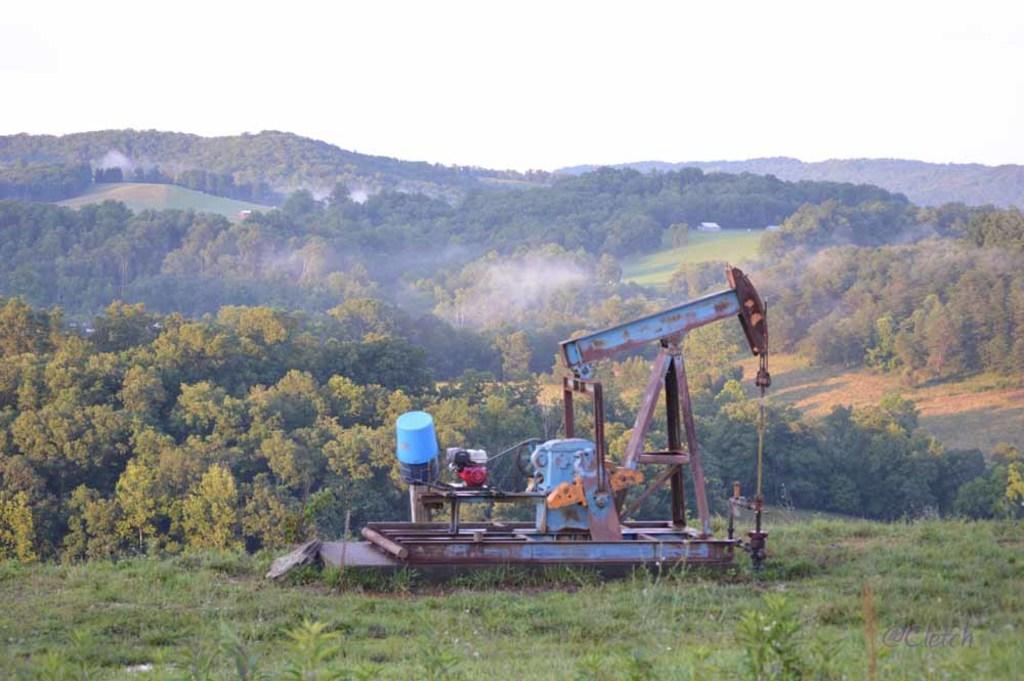What is the main object in the image? There is a machine with iron rods in the image. What can be seen on the ground in the image? There are plants on the ground in the image. What is visible in the background of the image? There are trees and the sky visible in the background of the image. Can you describe any additional features of the image? There is a watermark in the right bottom corner of the image. How does the machine exchange current with the plants in the image? There is no indication in the image that the machine is exchanging current with the plants, as the image does not show any electrical connections or interactions between the machine and the plants. 